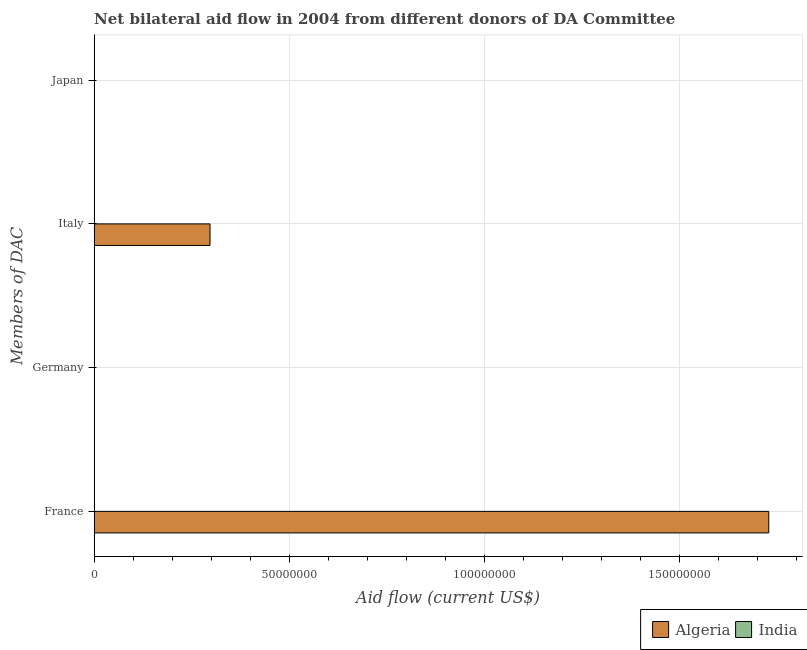How many bars are there on the 3rd tick from the top?
Your answer should be compact. 0. Across all countries, what is the maximum amount of aid given by france?
Keep it short and to the point. 1.73e+08. In which country was the amount of aid given by france maximum?
Offer a very short reply. Algeria. What is the total amount of aid given by france in the graph?
Keep it short and to the point. 1.73e+08. What is the difference between the amount of aid given by germany in India and the amount of aid given by italy in Algeria?
Provide a short and direct response. -2.97e+07. What is the difference between the highest and the lowest amount of aid given by italy?
Keep it short and to the point. 2.97e+07. How many bars are there?
Ensure brevity in your answer.  2. What is the difference between two consecutive major ticks on the X-axis?
Offer a terse response. 5.00e+07. Are the values on the major ticks of X-axis written in scientific E-notation?
Offer a terse response. No. How many legend labels are there?
Your response must be concise. 2. How are the legend labels stacked?
Offer a very short reply. Horizontal. What is the title of the graph?
Offer a terse response. Net bilateral aid flow in 2004 from different donors of DA Committee. Does "Micronesia" appear as one of the legend labels in the graph?
Your response must be concise. No. What is the label or title of the Y-axis?
Make the answer very short. Members of DAC. What is the Aid flow (current US$) of Algeria in France?
Offer a terse response. 1.73e+08. What is the Aid flow (current US$) in Algeria in Germany?
Provide a short and direct response. 0. What is the Aid flow (current US$) of India in Germany?
Give a very brief answer. 0. What is the Aid flow (current US$) in Algeria in Italy?
Your response must be concise. 2.97e+07. Across all Members of DAC, what is the maximum Aid flow (current US$) in Algeria?
Provide a short and direct response. 1.73e+08. What is the total Aid flow (current US$) of Algeria in the graph?
Keep it short and to the point. 2.03e+08. What is the total Aid flow (current US$) in India in the graph?
Provide a succinct answer. 0. What is the difference between the Aid flow (current US$) in Algeria in France and that in Italy?
Your answer should be very brief. 1.43e+08. What is the average Aid flow (current US$) in Algeria per Members of DAC?
Ensure brevity in your answer.  5.07e+07. What is the average Aid flow (current US$) in India per Members of DAC?
Provide a succinct answer. 0. What is the ratio of the Aid flow (current US$) in Algeria in France to that in Italy?
Make the answer very short. 5.82. What is the difference between the highest and the lowest Aid flow (current US$) of Algeria?
Offer a terse response. 1.73e+08. 